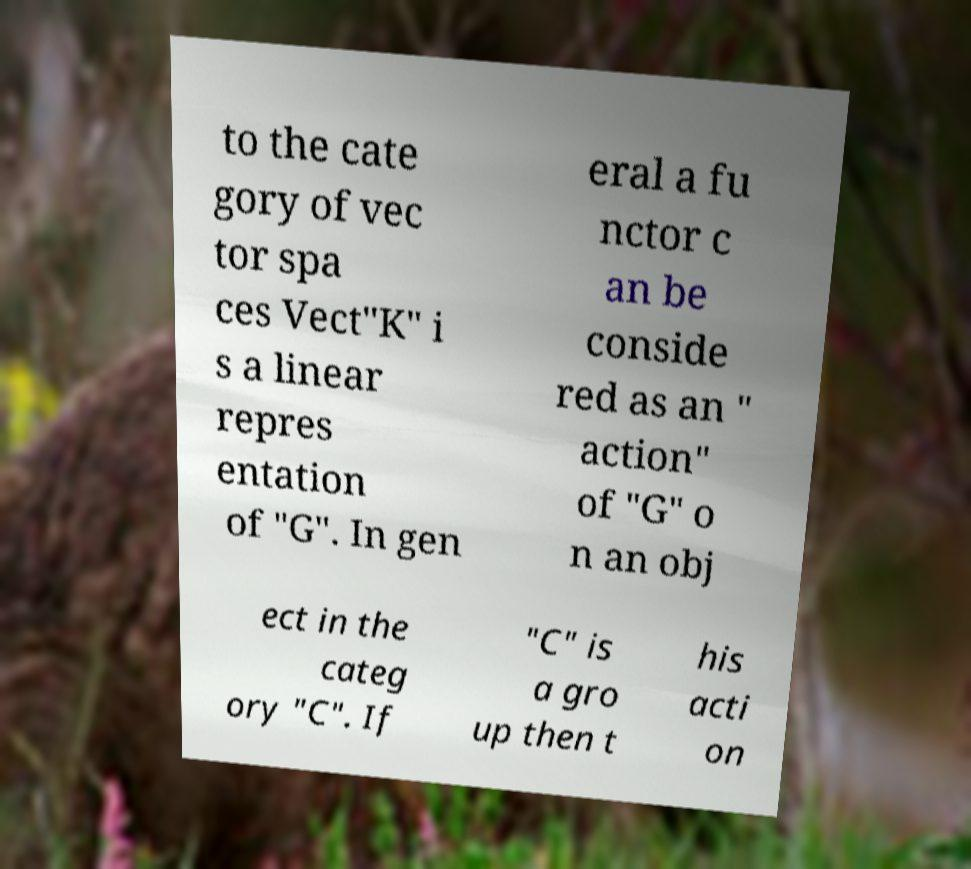Please read and relay the text visible in this image. What does it say? to the cate gory of vec tor spa ces Vect"K" i s a linear repres entation of "G". In gen eral a fu nctor c an be conside red as an " action" of "G" o n an obj ect in the categ ory "C". If "C" is a gro up then t his acti on 